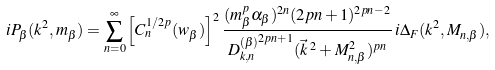<formula> <loc_0><loc_0><loc_500><loc_500>i P _ { \beta } ( k ^ { 2 } , m _ { \beta } ) = \sum _ { n = 0 } ^ { \infty } \left [ C _ { n } ^ { 1 / { 2 p } } ( w _ { \beta } ) \right ] ^ { 2 } \frac { ( m _ { \beta } ^ { p } \alpha _ { \beta } ) ^ { 2 n } ( 2 p n + 1 ) ^ { 2 p n - 2 } } { { D _ { k , n } ^ { ( \beta ) } } ^ { 2 p n + 1 } ( \vec { k } \, ^ { 2 } + M _ { n , \beta } ^ { 2 } ) ^ { p n } } \, i \Delta _ { F } ( k ^ { 2 } , M _ { n , \beta } ) ,</formula> 